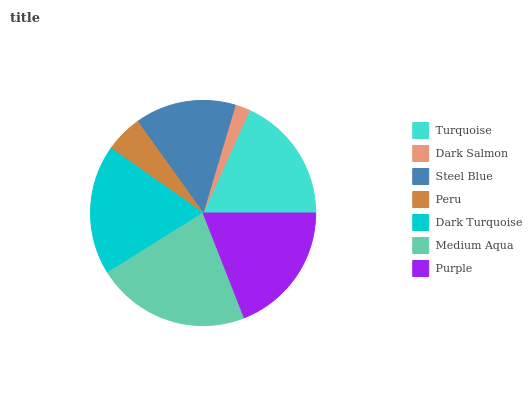Is Dark Salmon the minimum?
Answer yes or no. Yes. Is Medium Aqua the maximum?
Answer yes or no. Yes. Is Steel Blue the minimum?
Answer yes or no. No. Is Steel Blue the maximum?
Answer yes or no. No. Is Steel Blue greater than Dark Salmon?
Answer yes or no. Yes. Is Dark Salmon less than Steel Blue?
Answer yes or no. Yes. Is Dark Salmon greater than Steel Blue?
Answer yes or no. No. Is Steel Blue less than Dark Salmon?
Answer yes or no. No. Is Turquoise the high median?
Answer yes or no. Yes. Is Turquoise the low median?
Answer yes or no. Yes. Is Medium Aqua the high median?
Answer yes or no. No. Is Purple the low median?
Answer yes or no. No. 